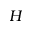<formula> <loc_0><loc_0><loc_500><loc_500>H</formula> 